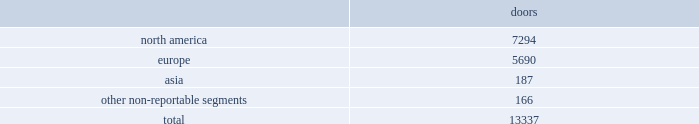No operating segments were aggregated to form our reportable segments .
In addition to these reportable segments , we also have other non-reportable segments , representing approximately 7% ( 7 % ) of our fiscal 2017 net revenues , which primarily consist of ( i ) sales of our club monaco branded products made through our retail businesses in the u.s. , canada , and europe , ( ii ) sales of our ralph lauren branded products made through our wholesale business in latin america , and ( iii ) royalty revenues earned through our global licensing alliances .
This new segment structure is consistent with how we establish our overall business strategy , allocate resources , and assess performance of our company .
All prior period segment information has been recast to reflect the realignment of our segment reporting structure on a comparable basis .
Approximately 40% ( 40 % ) of our fiscal 2017 net revenues were earned outside of the u.s .
See note 20 to the accompanying consolidated financial statements for a summary of net revenues and operating income by segment , as well as net revenues and long-lived assets by geographic location .
Our wholesale business our wholesale business sells our products globally to leading upscale and certain mid-tier department stores , specialty stores , and golf and pro shops .
We have continued to focus on elevating our brand by improving in-store product assortment and presentation , as well as full-price sell-throughs to consumers .
As of the end of fiscal 2017 , our wholesale products were sold through over 13000 doors worldwide , with the majority in specialty stores .
Our products are also sold through the e-commerce sites of certain of our wholesale customers .
The primary product offerings sold through our wholesale channels of distribution include apparel , accessories , and home furnishings .
Our luxury brands 2014 ralph lauren collection and ralph lauren purple label 2014 are distributed worldwide through a limited number of premier fashion retailers .
Department stores are our major wholesale customers in north america .
In latin america , our wholesale products are sold in department stores and specialty stores .
In europe , our wholesale sales are comprised of a varying mix of sales to both department stores and specialty stores , depending on the country .
In asia , our wholesale products are distributed primarily through shop-within-shops at department stores .
We also distribute our wholesale products to certain licensed stores operated by our partners in latin america , asia , europe , and the middle east .
We sell the majority of our excess and out-of-season products through secondary distribution channels worldwide , including our retail factory stores .
Worldwide wholesale distribution channels the table presents the number of wholesale doors by segment as of april 1 , 2017: .
We have three key wholesale customers that generate significant sales volume .
During fiscal 2017 , sales to our largest wholesale customer , macy's , inc .
( "macy's" ) , accounted for approximately 10% ( 10 % ) of our total net revenues .
Further , during fiscal 2017 , sales to our three largest wholesale customers , including macy's , accounted for approximately 21% ( 21 % ) of our total net revenues .
Substantially all sales to our three largest wholesale customers related to our north america segment .
Our products are sold primarily by our own sales forces .
Our wholesale business maintains its primary showrooms in new york city .
In addition , we maintain regional showrooms in milan , paris , london , munich , madrid , stockholm , and panama. .
What percentage of wholesale doors as of april 1 , 2017 where in the asia segment? 
Computations: (187 / 13337)
Answer: 0.01402. 